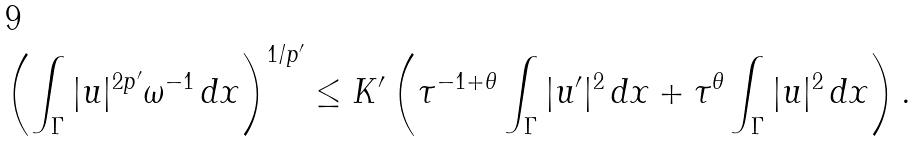<formula> <loc_0><loc_0><loc_500><loc_500>\left ( \int _ { \Gamma } | u | ^ { 2 p ^ { \prime } } \omega ^ { - 1 } \, d x \right ) ^ { 1 / p ^ { \prime } } \leq K ^ { \prime } \left ( \tau ^ { - 1 + \theta } \int _ { \Gamma } | u ^ { \prime } | ^ { 2 } \, d x + \tau ^ { \theta } \int _ { \Gamma } | u | ^ { 2 } \, d x \right ) .</formula> 